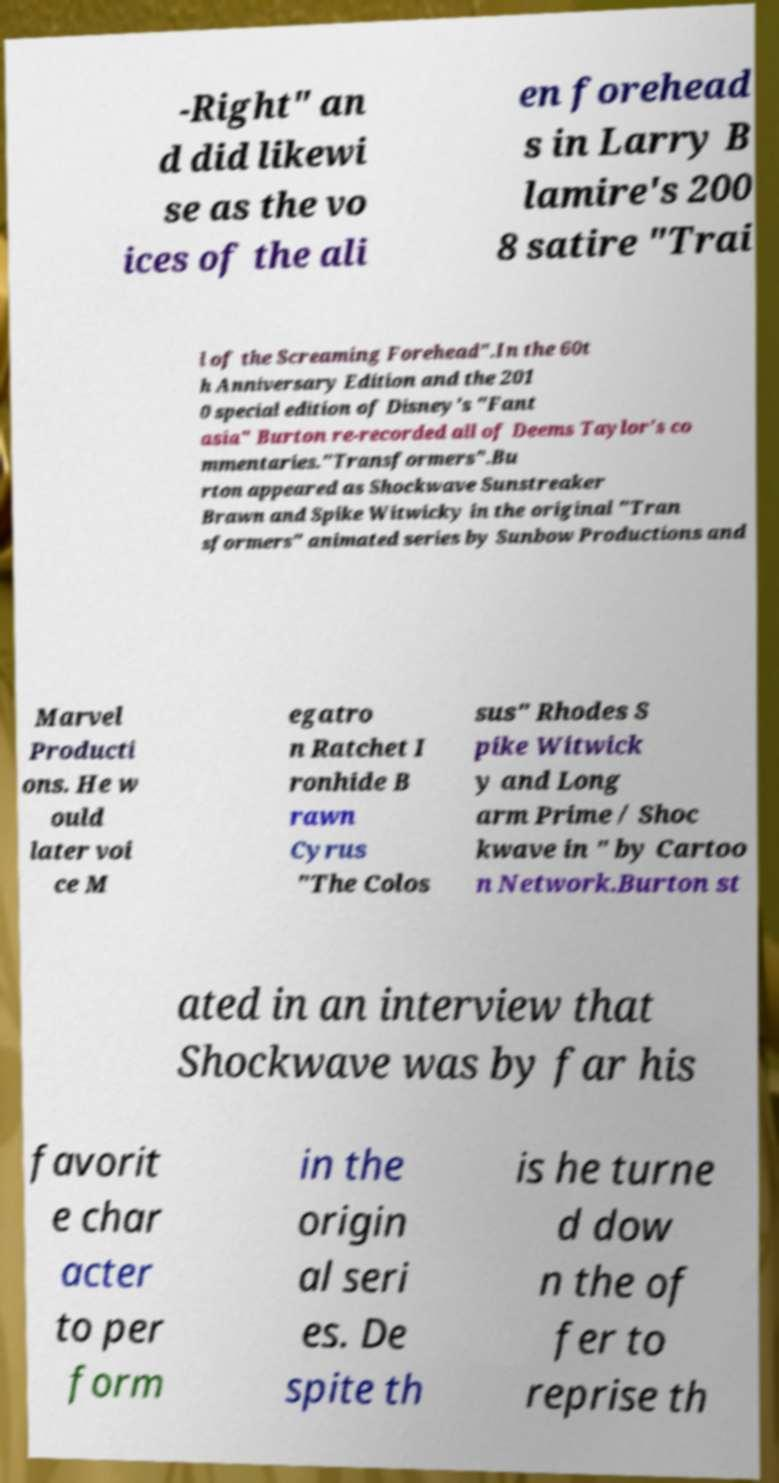There's text embedded in this image that I need extracted. Can you transcribe it verbatim? -Right" an d did likewi se as the vo ices of the ali en forehead s in Larry B lamire's 200 8 satire "Trai l of the Screaming Forehead".In the 60t h Anniversary Edition and the 201 0 special edition of Disney's "Fant asia" Burton re-recorded all of Deems Taylor's co mmentaries."Transformers".Bu rton appeared as Shockwave Sunstreaker Brawn and Spike Witwicky in the original "Tran sformers" animated series by Sunbow Productions and Marvel Producti ons. He w ould later voi ce M egatro n Ratchet I ronhide B rawn Cyrus "The Colos sus" Rhodes S pike Witwick y and Long arm Prime / Shoc kwave in " by Cartoo n Network.Burton st ated in an interview that Shockwave was by far his favorit e char acter to per form in the origin al seri es. De spite th is he turne d dow n the of fer to reprise th 